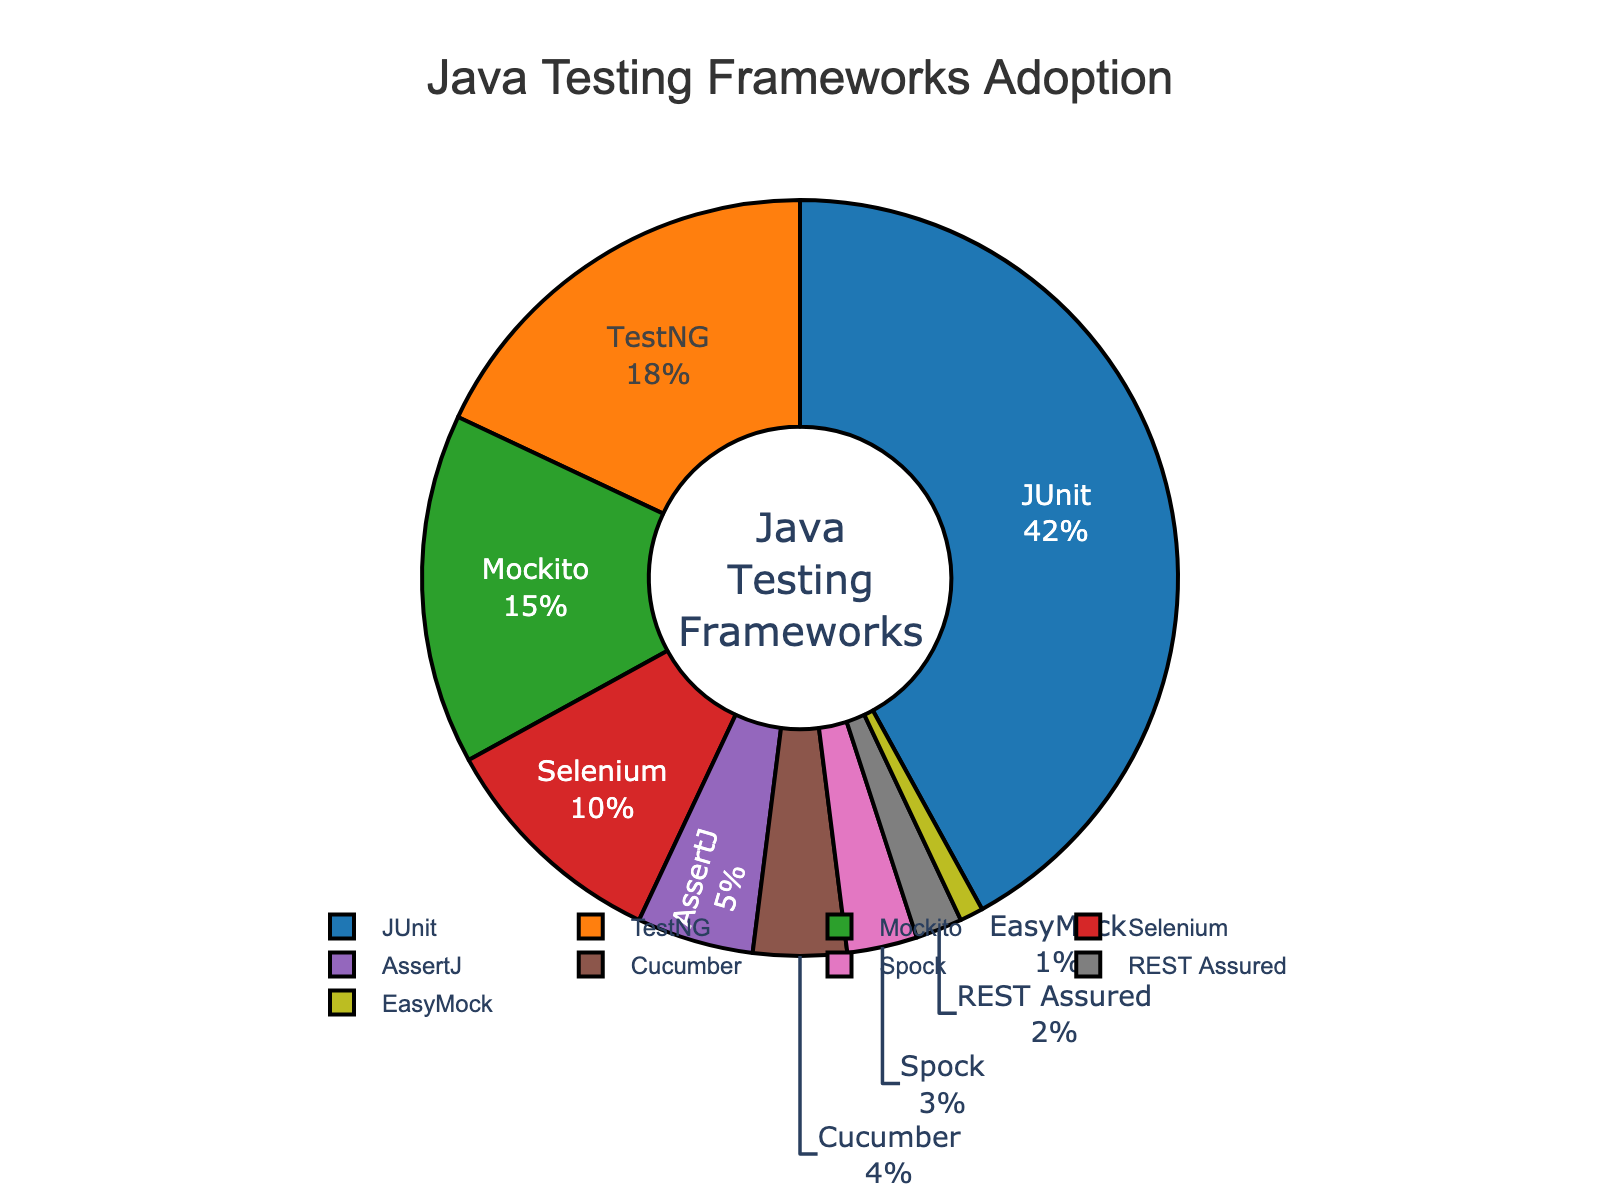What's the most popular Java testing framework in the pie chart? Look at the pie chart to identify which segment occupies the largest portion. According to the data labels, identify the framework associated with this largest portion.
Answer: JUnit What's the combined percentage of projects using Mockito and TestNG? Find and sum the percentages for Mockito (15%) and TestNG (18%). 15 + 18 = 33
Answer: 33% Which frameworks have less than 5% adoption? Examine the chart and identify segments with percentages below 5%. These are AssertJ (5%), Cucumber (4%), Spock (3%), REST Assured (2%), and EasyMock (1%).
Answer: Cucumber, Spock, REST Assured, EasyMock Which frameworks have a higher adoption rate than Selenium? Locate the section labeled Selenium (10%) and find all sections that represent a percentage greater than 10%. These are JUnit (42%), TestNG (18%), and Mockito (15%).
Answer: JUnit, TestNG, Mockito What is the percentage difference between the highest and lowest adoption rates in the chart? Identify the framework with the highest percentage (JUnit, 42%) and the one with the lowest (EasyMock, 1%). Subtract the smallest percentage from the largest: 42 - 1 = 41
Answer: 41% If you sum the percentages of all frameworks other than JUnit, what's the result? Subtract the JUnit percentage (42%) from the total percentage (100%) to get the combined percentage for all other frameworks. 100 - 42 = 58
Answer: 58% Which framework's segment is colored orange in the pie chart? Refer to the color scheme used in the chart. The segment colored orange corresponds to the second color in the palette provided, which is TestNG.
Answer: TestNG How much more popular is Mockito compared to Cucumber? Find the percentages for Mockito (15%) and Cucumber (4%) and subtract the smaller percentage from the larger one: 15 - 4 = 11
Answer: 11% What fraction of projects use TestNG and Selenium combined, expressed as a simplified fraction? Sum the percentages for TestNG (18%) and Selenium (10%) to get 28. Divide 28 by 100 to convert to a fraction: 28/100. Simplify by dividing by the greatest common divisor, which is 4, resulting in 7/25.
Answer: 7/25 Excluding JUnit, what is the average percentage adoption of the remaining frameworks? Sum the percentages for all frameworks except JUnit: 18 (TestNG) + 15 (Mockito) + 10 (Selenium) + 5 (AssertJ) + 4 (Cucumber) + 3 (Spock) + 2 (REST Assured) + 1 (EasyMock) = 58. There are 8 frameworks, so divide 58 by 8: 58/8 = 7.25
Answer: 7.25% 